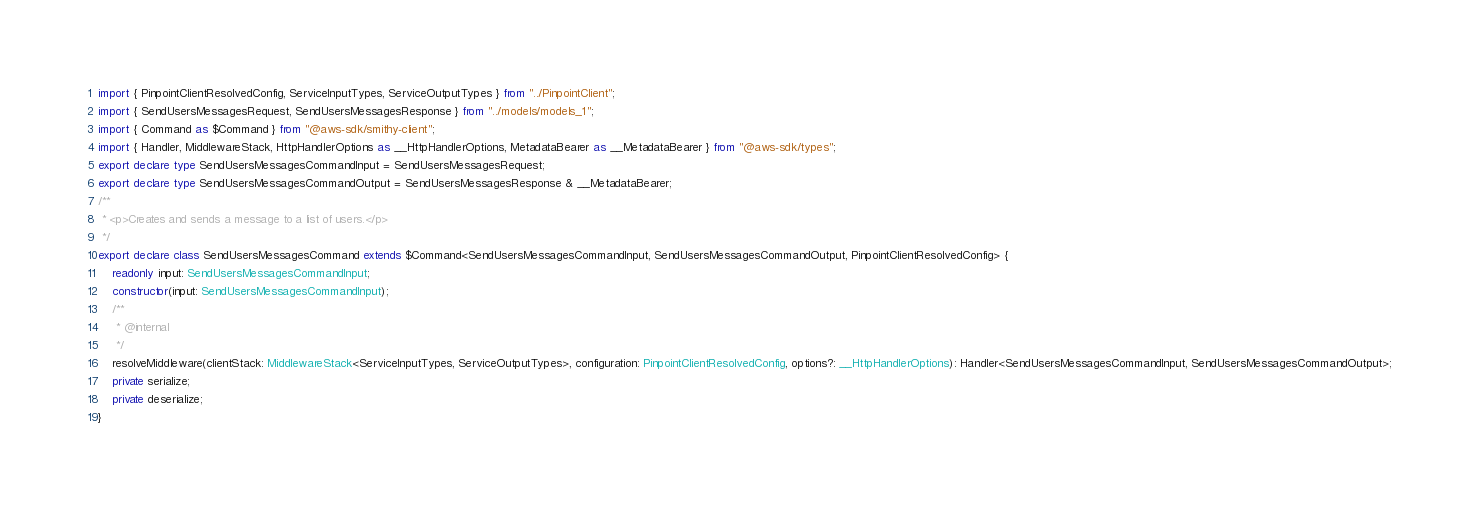<code> <loc_0><loc_0><loc_500><loc_500><_TypeScript_>import { PinpointClientResolvedConfig, ServiceInputTypes, ServiceOutputTypes } from "../PinpointClient";
import { SendUsersMessagesRequest, SendUsersMessagesResponse } from "../models/models_1";
import { Command as $Command } from "@aws-sdk/smithy-client";
import { Handler, MiddlewareStack, HttpHandlerOptions as __HttpHandlerOptions, MetadataBearer as __MetadataBearer } from "@aws-sdk/types";
export declare type SendUsersMessagesCommandInput = SendUsersMessagesRequest;
export declare type SendUsersMessagesCommandOutput = SendUsersMessagesResponse & __MetadataBearer;
/**
 * <p>Creates and sends a message to a list of users.</p>
 */
export declare class SendUsersMessagesCommand extends $Command<SendUsersMessagesCommandInput, SendUsersMessagesCommandOutput, PinpointClientResolvedConfig> {
    readonly input: SendUsersMessagesCommandInput;
    constructor(input: SendUsersMessagesCommandInput);
    /**
     * @internal
     */
    resolveMiddleware(clientStack: MiddlewareStack<ServiceInputTypes, ServiceOutputTypes>, configuration: PinpointClientResolvedConfig, options?: __HttpHandlerOptions): Handler<SendUsersMessagesCommandInput, SendUsersMessagesCommandOutput>;
    private serialize;
    private deserialize;
}
</code> 